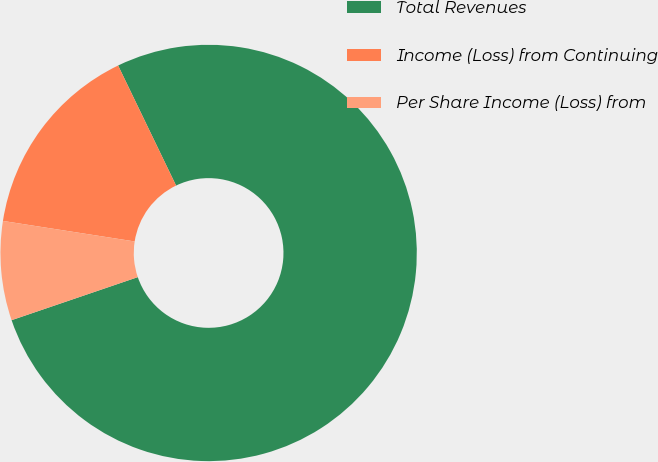<chart> <loc_0><loc_0><loc_500><loc_500><pie_chart><fcel>Total Revenues<fcel>Income (Loss) from Continuing<fcel>Per Share Income (Loss) from<nl><fcel>76.92%<fcel>15.38%<fcel>7.69%<nl></chart> 